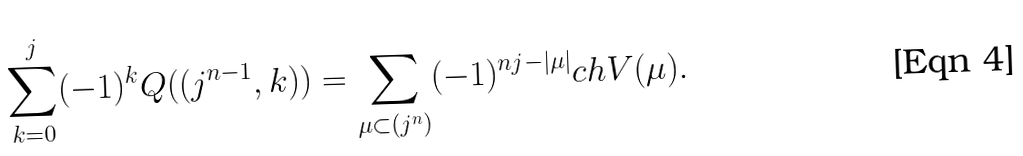Convert formula to latex. <formula><loc_0><loc_0><loc_500><loc_500>\sum _ { k = 0 } ^ { j } ( - 1 ) ^ { k } Q ( ( j ^ { n - 1 } , k ) ) = \sum _ { \mu \subset ( j ^ { n } ) } ( - 1 ) ^ { n j - | \mu | } c h V ( \mu ) .</formula> 